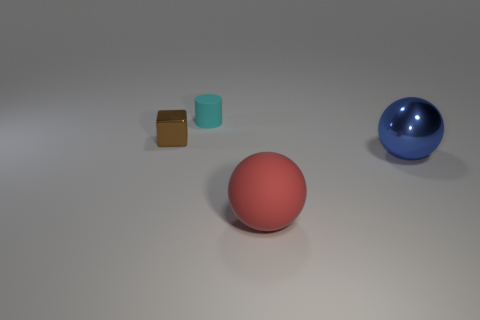There is a matte object on the left side of the rubber object that is in front of the small cube; what shape is it?
Your response must be concise. Cylinder. How many cylinders are cyan things or tiny blue metallic objects?
Your answer should be very brief. 1. Do the metallic object on the right side of the large red matte thing and the brown thing that is behind the large blue shiny thing have the same shape?
Give a very brief answer. No. What color is the thing that is both in front of the tiny cyan cylinder and on the left side of the red sphere?
Make the answer very short. Brown. There is a large metal sphere; is it the same color as the tiny object that is in front of the small cylinder?
Your response must be concise. No. What is the size of the object that is both behind the big blue thing and to the right of the tiny brown shiny object?
Offer a terse response. Small. How many other objects are there of the same color as the metallic cube?
Provide a succinct answer. 0. There is a thing that is to the right of the sphere on the left side of the sphere that is to the right of the red ball; what is its size?
Keep it short and to the point. Large. Are there any red objects to the left of the big rubber object?
Ensure brevity in your answer.  No. Do the shiny ball and the matte thing that is to the left of the big red matte thing have the same size?
Your response must be concise. No. 